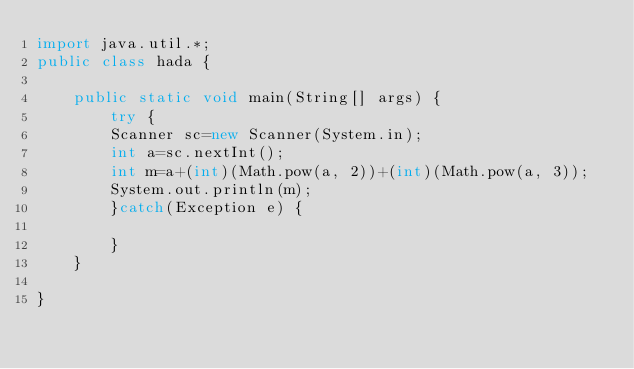<code> <loc_0><loc_0><loc_500><loc_500><_Java_>import java.util.*;
public class hada {

	public static void main(String[] args) {
		try {
		Scanner sc=new Scanner(System.in);
		int a=sc.nextInt();
		int m=a+(int)(Math.pow(a, 2))+(int)(Math.pow(a, 3));
		System.out.println(m);
		}catch(Exception e) {
			
		}
	}

}</code> 